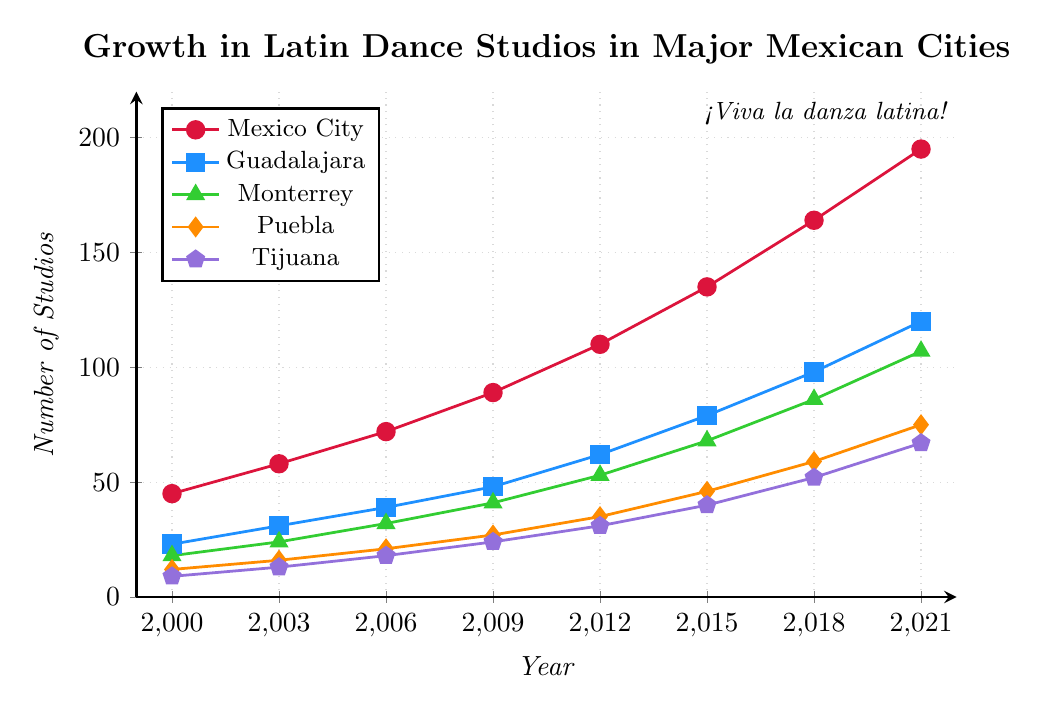Which city had the highest number of Latin dance studios in 2021? By observing the plot, we can see that the red line representing Mexico City is at the highest position in 2021.
Answer: Mexico City How many more dance studios were in Monterrey than in Puebla in 2015? The plot shows Monterrey (green) had around 68 studios, and Puebla (orange) had around 46 studios in 2015. The difference is 68 - 46.
Answer: 22 Which city experienced the largest growth in Latin dance studios between 2000 and 2021? Compare the starting and ending values of each city's line. Mexico City (red) grew from 45 to 195, which is the largest increase of 195 - 45.
Answer: Mexico City What was the total number of Latin dance studios in all five cities in 2009? Sum the values from the plot for each city in 2009: 89 (Mexico City) + 48 (Guadalajara) + 41 (Monterrey) + 27 (Puebla) + 24 (Tijuana). The sum is 89 + 48 + 41 + 27 + 24.
Answer: 229 Which city had the smallest number of Latin dance studios in 2012? Observing the plot for 2012, Tijuana (purple) has the lowest position compared to other cities.
Answer: Tijuana By how much did Guadalajara’s number of Latin dance studios increase between 2006 and 2015? In 2006, Guadalajara (blue) had 39 studios, and in 2015, it had 79 studios. The increase is 79 - 39.
Answer: 40 What is the average number of Latin dance studios in Mexico City over the given years? Add the values for Mexico City (45, 58, 72, 89, 110, 135, 164, 195) and divide by the number of data points (8). The sum is 868, so the average is 868/8.
Answer: 108.5 In which year did Puebla surpass 50 Latin dance studios? Identify the point in the plot where Puebla (orange) goes above 50. According to the plot, it happened between 2015 and 2018. 2018 is the first point above 50.
Answer: 2018 